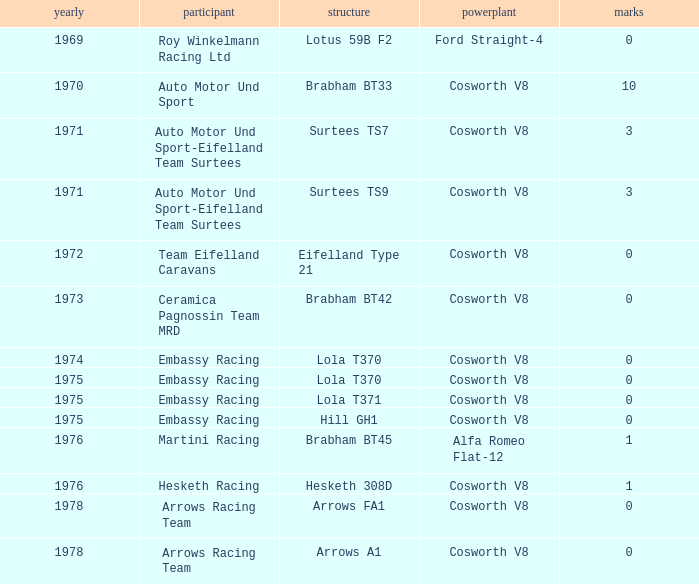Who was the entrant in 1971? Auto Motor Und Sport-Eifelland Team Surtees, Auto Motor Und Sport-Eifelland Team Surtees. 